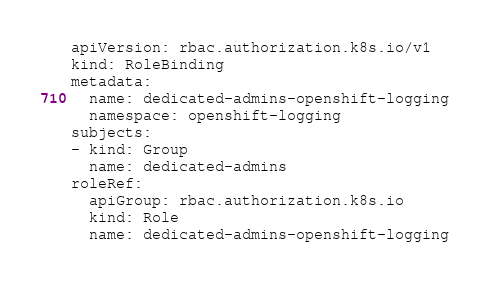Convert code to text. <code><loc_0><loc_0><loc_500><loc_500><_YAML_>apiVersion: rbac.authorization.k8s.io/v1
kind: RoleBinding
metadata:
  name: dedicated-admins-openshift-logging
  namespace: openshift-logging
subjects:
- kind: Group
  name: dedicated-admins
roleRef:
  apiGroup: rbac.authorization.k8s.io
  kind: Role
  name: dedicated-admins-openshift-logging
</code> 